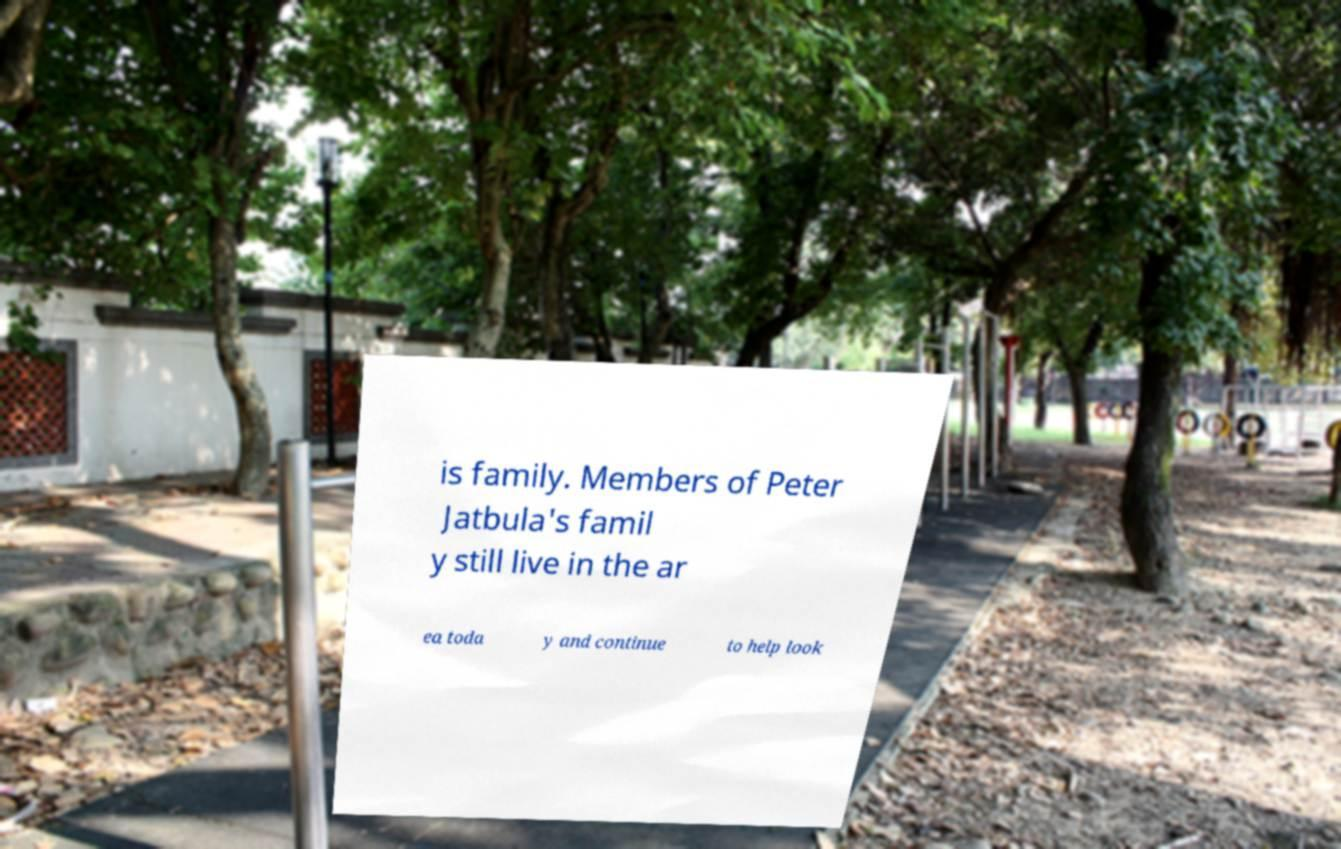What messages or text are displayed in this image? I need them in a readable, typed format. is family. Members of Peter Jatbula's famil y still live in the ar ea toda y and continue to help look 